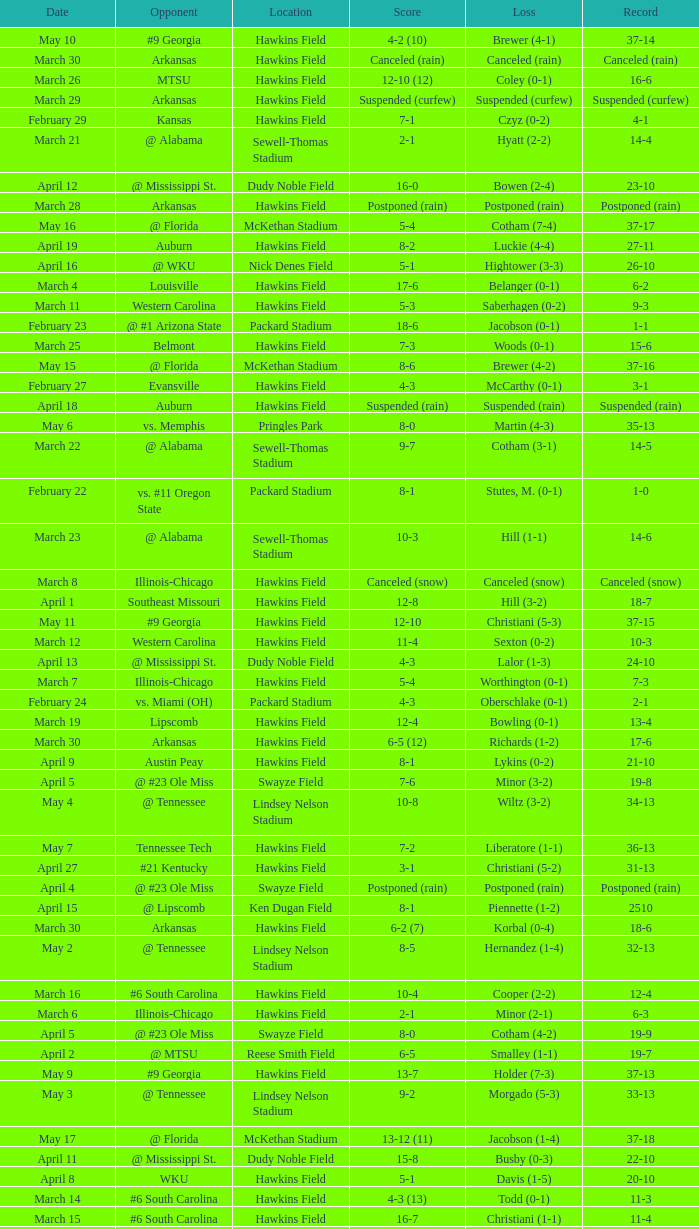What was the location of the game when the record was 2-1? Packard Stadium. 